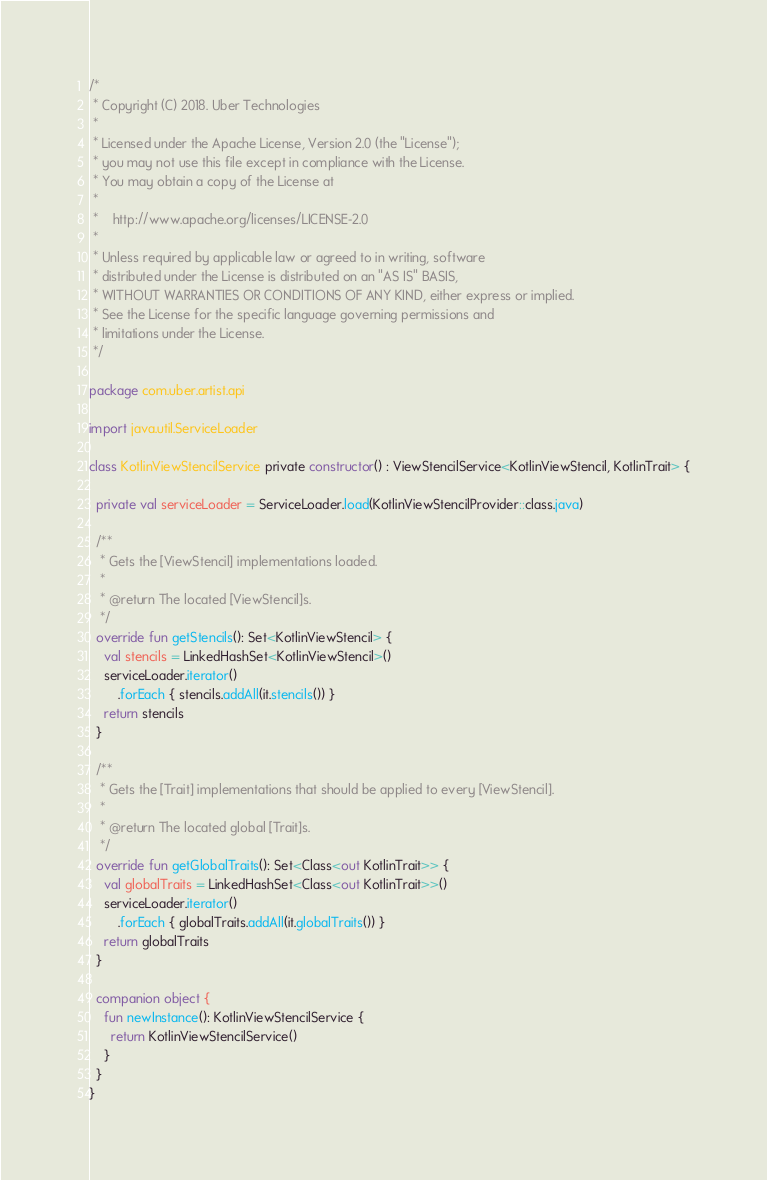Convert code to text. <code><loc_0><loc_0><loc_500><loc_500><_Kotlin_>/*
 * Copyright (C) 2018. Uber Technologies
 *
 * Licensed under the Apache License, Version 2.0 (the "License");
 * you may not use this file except in compliance with the License.
 * You may obtain a copy of the License at
 *
 *    http://www.apache.org/licenses/LICENSE-2.0
 *
 * Unless required by applicable law or agreed to in writing, software
 * distributed under the License is distributed on an "AS IS" BASIS,
 * WITHOUT WARRANTIES OR CONDITIONS OF ANY KIND, either express or implied.
 * See the License for the specific language governing permissions and
 * limitations under the License.
 */

package com.uber.artist.api

import java.util.ServiceLoader

class KotlinViewStencilService private constructor() : ViewStencilService<KotlinViewStencil, KotlinTrait> {

  private val serviceLoader = ServiceLoader.load(KotlinViewStencilProvider::class.java)

  /**
   * Gets the [ViewStencil] implementations loaded.
   *
   * @return The located [ViewStencil]s.
   */
  override fun getStencils(): Set<KotlinViewStencil> {
    val stencils = LinkedHashSet<KotlinViewStencil>()
    serviceLoader.iterator()
        .forEach { stencils.addAll(it.stencils()) }
    return stencils
  }

  /**
   * Gets the [Trait] implementations that should be applied to every [ViewStencil].
   *
   * @return The located global [Trait]s.
   */
  override fun getGlobalTraits(): Set<Class<out KotlinTrait>> {
    val globalTraits = LinkedHashSet<Class<out KotlinTrait>>()
    serviceLoader.iterator()
        .forEach { globalTraits.addAll(it.globalTraits()) }
    return globalTraits
  }

  companion object {
    fun newInstance(): KotlinViewStencilService {
      return KotlinViewStencilService()
    }
  }
}
</code> 